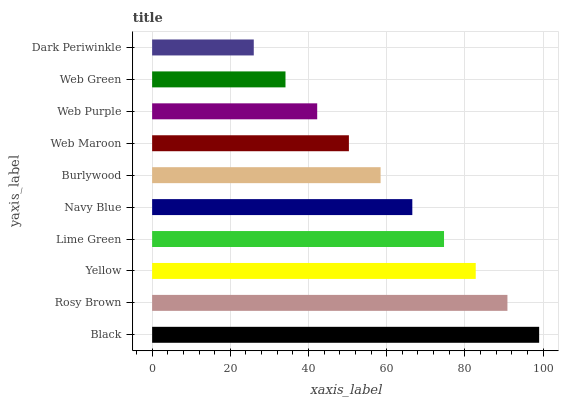Is Dark Periwinkle the minimum?
Answer yes or no. Yes. Is Black the maximum?
Answer yes or no. Yes. Is Rosy Brown the minimum?
Answer yes or no. No. Is Rosy Brown the maximum?
Answer yes or no. No. Is Black greater than Rosy Brown?
Answer yes or no. Yes. Is Rosy Brown less than Black?
Answer yes or no. Yes. Is Rosy Brown greater than Black?
Answer yes or no. No. Is Black less than Rosy Brown?
Answer yes or no. No. Is Navy Blue the high median?
Answer yes or no. Yes. Is Burlywood the low median?
Answer yes or no. Yes. Is Black the high median?
Answer yes or no. No. Is Lime Green the low median?
Answer yes or no. No. 